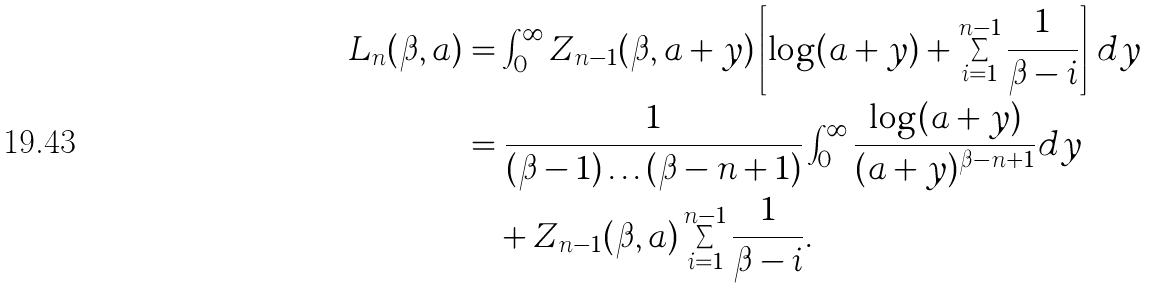<formula> <loc_0><loc_0><loc_500><loc_500>L _ { n } ( \beta , a ) & = \int _ { 0 } ^ { \infty } Z _ { n - 1 } ( \beta , a + y ) \left [ \log ( a + y ) + \sum _ { i = 1 } ^ { n - 1 } \frac { 1 } { \beta - i } \right ] \, d y \\ & = \frac { 1 } { ( \beta - 1 ) \dots ( \beta - n + 1 ) } \int _ { 0 } ^ { \infty } \frac { \log ( a + y ) } { ( a + y ) ^ { \beta - n + 1 } } d y \\ & \quad + Z _ { n - 1 } ( \beta , a ) \sum _ { i = 1 } ^ { n - 1 } \frac { 1 } { \beta - i } .</formula> 